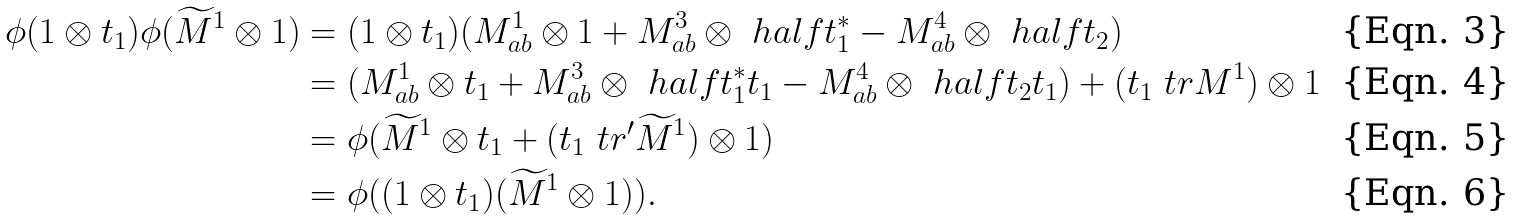<formula> <loc_0><loc_0><loc_500><loc_500>\phi ( 1 \otimes t _ { 1 } ) \phi ( \widetilde { M } ^ { 1 } \otimes 1 ) & = ( 1 \otimes t _ { 1 } ) ( M ^ { 1 } _ { a b } \otimes 1 + M ^ { 3 } _ { a b } \otimes \ h a l f t _ { 1 } ^ { * } - M ^ { 4 } _ { a b } \otimes \ h a l f t _ { 2 } ) \\ & = ( M ^ { 1 } _ { a b } \otimes t _ { 1 } + M ^ { 3 } _ { a b } \otimes \ h a l f t _ { 1 } ^ { * } t _ { 1 } - M ^ { 4 } _ { a b } \otimes \ h a l f t _ { 2 } t _ { 1 } ) + ( t _ { 1 } \ t r M ^ { 1 } ) \otimes 1 \\ & = \phi ( \widetilde { M } ^ { 1 } \otimes t _ { 1 } + ( t _ { 1 } \ t r ^ { \prime } \widetilde { M } ^ { 1 } ) \otimes 1 ) \\ & = \phi ( ( 1 \otimes t _ { 1 } ) ( \widetilde { M } ^ { 1 } \otimes 1 ) ) .</formula> 